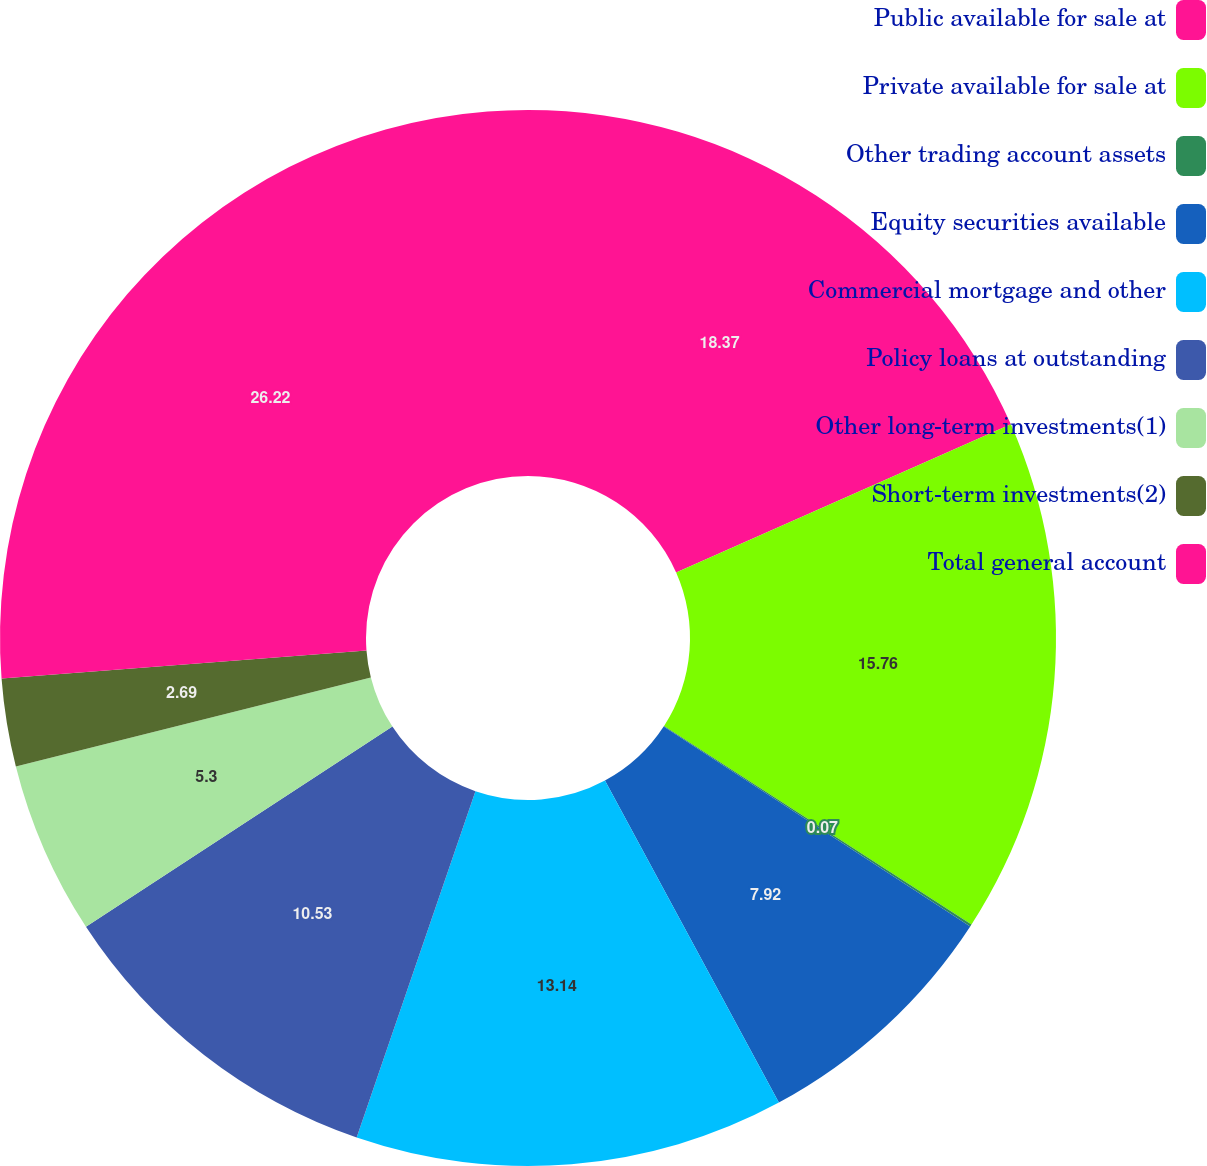<chart> <loc_0><loc_0><loc_500><loc_500><pie_chart><fcel>Public available for sale at<fcel>Private available for sale at<fcel>Other trading account assets<fcel>Equity securities available<fcel>Commercial mortgage and other<fcel>Policy loans at outstanding<fcel>Other long-term investments(1)<fcel>Short-term investments(2)<fcel>Total general account<nl><fcel>18.37%<fcel>15.76%<fcel>0.07%<fcel>7.92%<fcel>13.14%<fcel>10.53%<fcel>5.3%<fcel>2.69%<fcel>26.22%<nl></chart> 